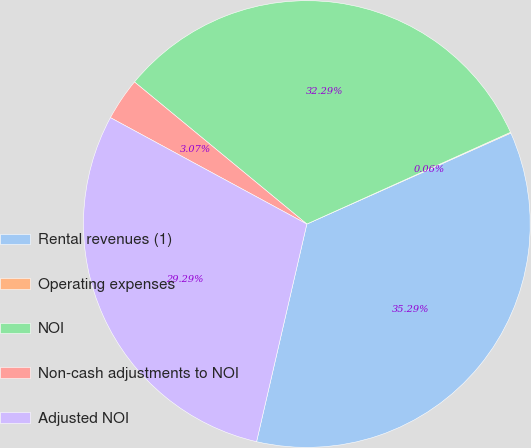Convert chart. <chart><loc_0><loc_0><loc_500><loc_500><pie_chart><fcel>Rental revenues (1)<fcel>Operating expenses<fcel>NOI<fcel>Non-cash adjustments to NOI<fcel>Adjusted NOI<nl><fcel>35.29%<fcel>0.06%<fcel>32.29%<fcel>3.07%<fcel>29.29%<nl></chart> 